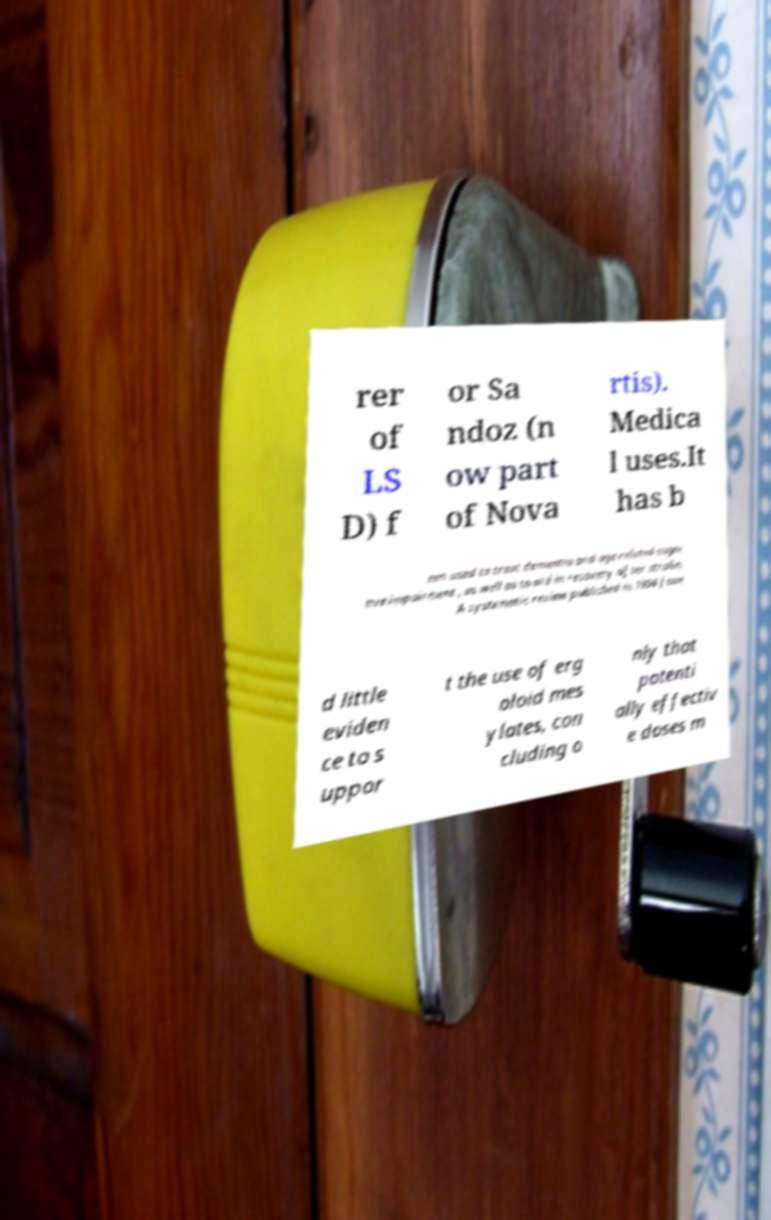Can you accurately transcribe the text from the provided image for me? rer of LS D) f or Sa ndoz (n ow part of Nova rtis). Medica l uses.It has b een used to treat dementia and age-related cogni tive impairment , as well as to aid in recovery after stroke. A systematic review published in 1994 foun d little eviden ce to s uppor t the use of erg oloid mes ylates, con cluding o nly that potenti ally effectiv e doses m 